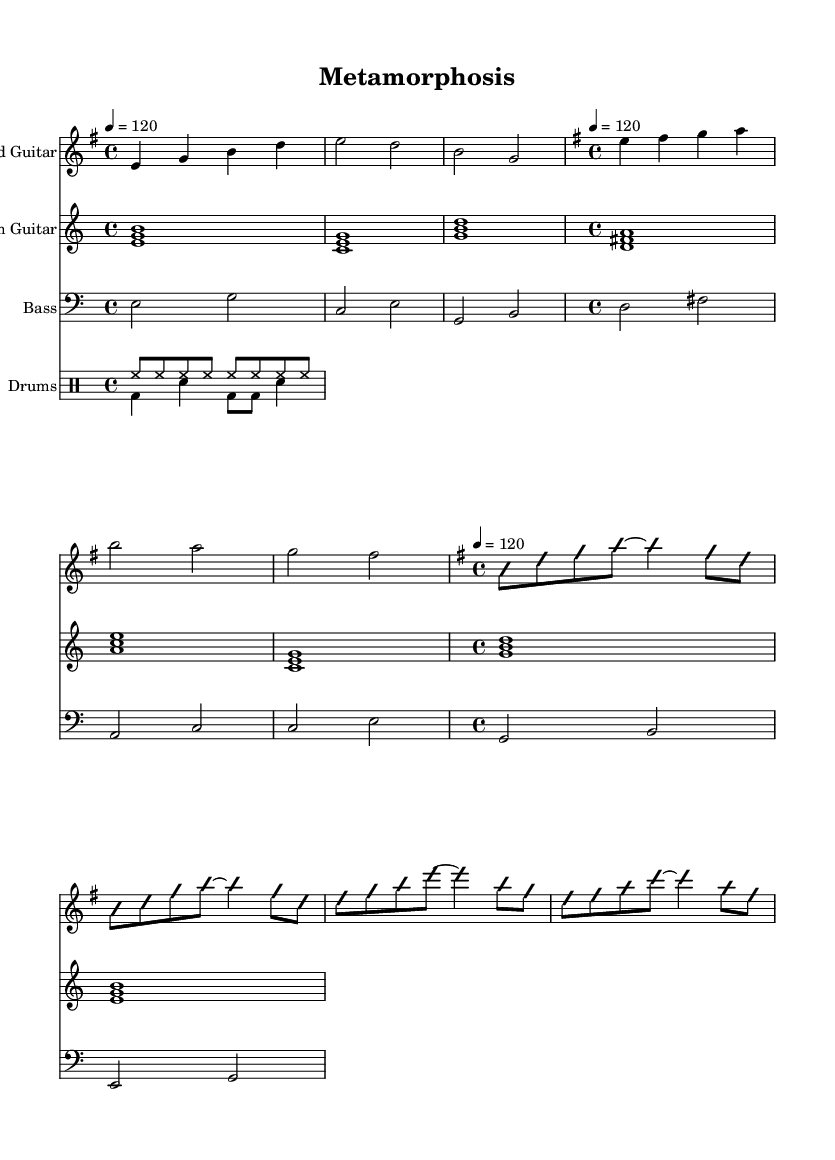What is the key signature of this music? The key signature is E minor, which has one sharp (F#). This is indicated at the beginning of the sheet music where the key signature is displayed.
Answer: E minor What is the time signature of this music? The time signature is 4/4, which means there are four beats in a measure and a quarter note receives one beat. This is shown at the beginning of the sheet music next to the key signature.
Answer: 4/4 What is the tempo marking for this piece? The tempo marking is quarter note equals 120, indicating that there are 120 beats per minute. This is indicated in the tempo section of the score.
Answer: 120 How many measures are in the main melody? The main melody consists of three measures. This can be counted by looking at the bar lines that separate the different musical phrases in that part.
Answer: 3 What type of improvisation is indicated in the guitar solo? The score indicates 'improvisation on' and 'improvisation off', suggesting that the guitarist is expected to play freely within the structure during that section. This is explicitly noted in the guitar solo part of the sheet music.
Answer: Improvisation What is the primary chord progression used in the rhythm guitar section? The primary chord progression is E minor, C, G, D, A minor, C, G, E minor. Each of these chords corresponds to a measure, and they follow a pattern throughout the rhythm guitar part.
Answer: E minor, C, G, D, A minor, C, G, E minor What instruments are included in this score? The score includes Lead Guitar, Rhythm Guitar, Bass, and Drums. This is seen at the beginning of each staff in the score, where the instrument names are listed.
Answer: Lead Guitar, Rhythm Guitar, Bass, Drums 